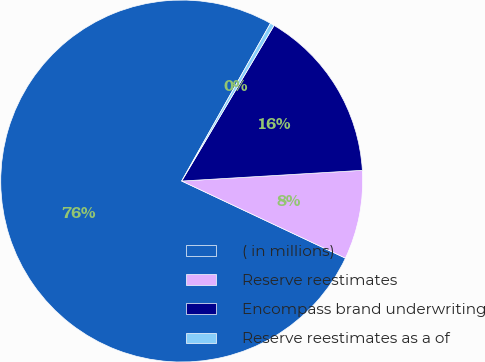<chart> <loc_0><loc_0><loc_500><loc_500><pie_chart><fcel>( in millions)<fcel>Reserve reestimates<fcel>Encompass brand underwriting<fcel>Reserve reestimates as a of<nl><fcel>76.16%<fcel>7.95%<fcel>15.53%<fcel>0.37%<nl></chart> 